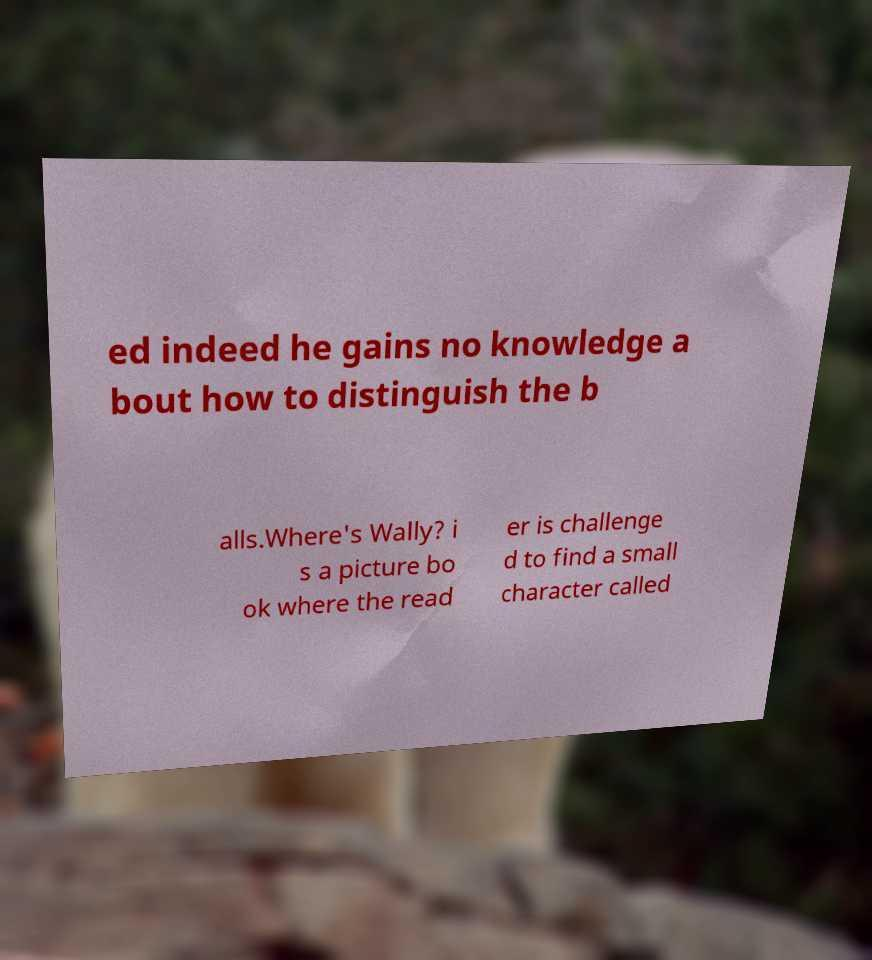Could you extract and type out the text from this image? ed indeed he gains no knowledge a bout how to distinguish the b alls.Where's Wally? i s a picture bo ok where the read er is challenge d to find a small character called 